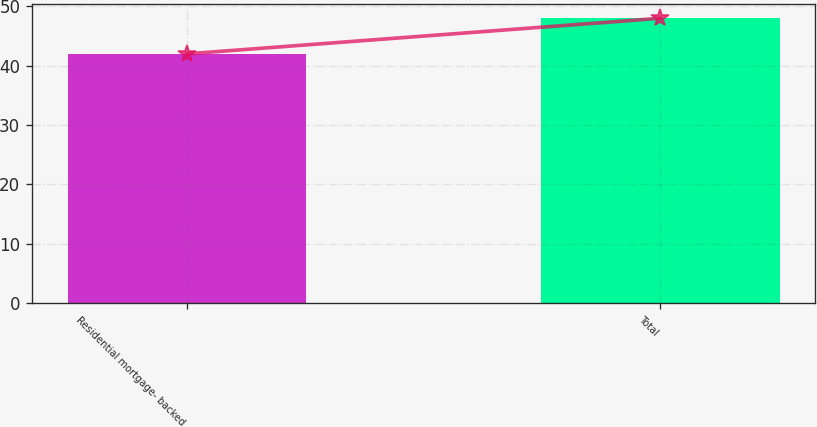<chart> <loc_0><loc_0><loc_500><loc_500><bar_chart><fcel>Residential mortgage- backed<fcel>Total<nl><fcel>42<fcel>48<nl></chart> 